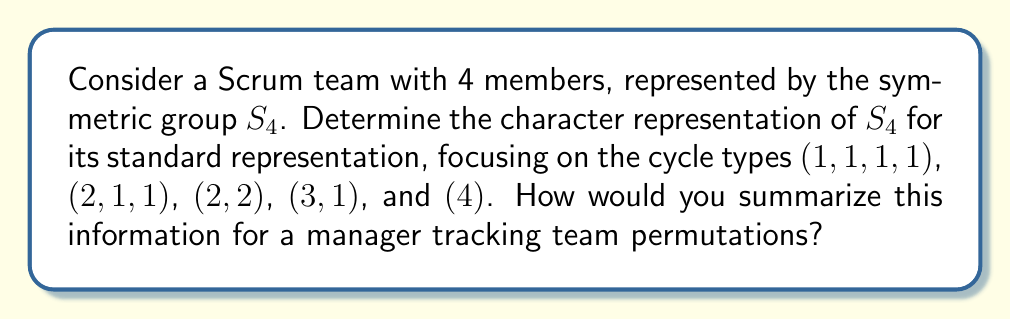Can you answer this question? To determine the character representation of $S_4$ for its standard representation:

1. Identify the conjugacy classes of $S_4$:
   - (1,1,1,1): identity permutation
   - (2,1,1): transpositions
   - (2,2): double transpositions
   - (3,1): 3-cycles
   - (4): 4-cycles

2. Calculate the character values for each conjugacy class:

   a) For (1,1,1,1):
      $\chi(e) = 4$ (dimension of the representation)

   b) For (2,1,1):
      $\chi((1,2)) = 2$ (2 fixed points)

   c) For (2,2):
      $\chi((1,2)(3,4)) = 0$ (no fixed points)

   d) For (3,1):
      $\chi((1,2,3)) = 1$ (1 fixed point)

   e) For (4):
      $\chi((1,2,3,4)) = 0$ (no fixed points)

3. Construct the character table:

   $$\begin{array}{c|ccccc}
   \text{Cycle type} & (1,1,1,1) & (2,1,1) & (2,2) & (3,1) & (4) \\
   \hline
   \chi & 4 & 2 & 0 & 1 & 0
   \end{array}$$

4. Interpret for a manager:
   - The character values represent the number of team members unchanged by each permutation type.
   - Higher values indicate less disruption to the team structure.
   - This information can help track how different team reorganizations might impact productivity and collaboration.
Answer: $\chi = (4, 2, 0, 1, 0)$ 